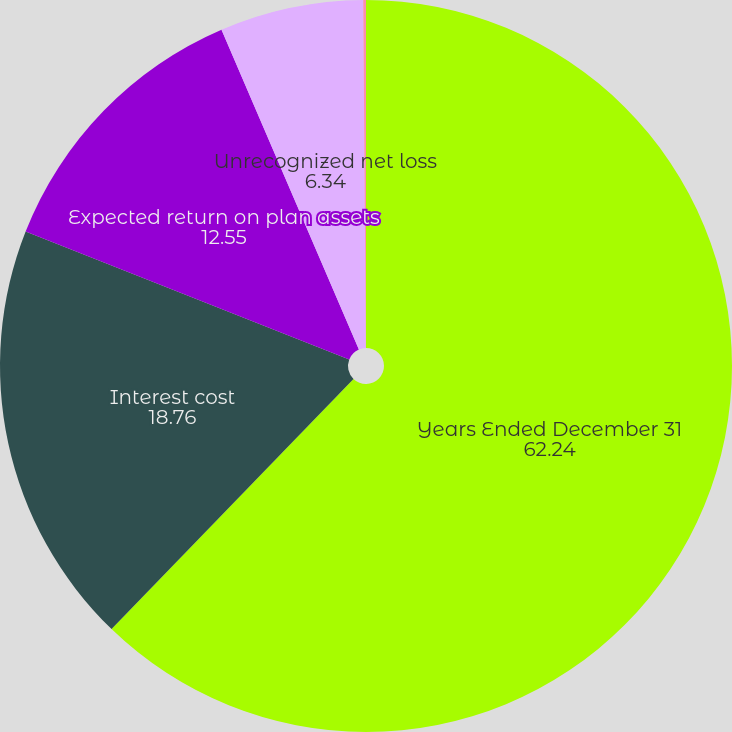Convert chart. <chart><loc_0><loc_0><loc_500><loc_500><pie_chart><fcel>Years Ended December 31<fcel>Interest cost<fcel>Expected return on plan assets<fcel>Unrecognized net loss<fcel>Unrecognized prior service<nl><fcel>62.24%<fcel>18.76%<fcel>12.55%<fcel>6.34%<fcel>0.12%<nl></chart> 